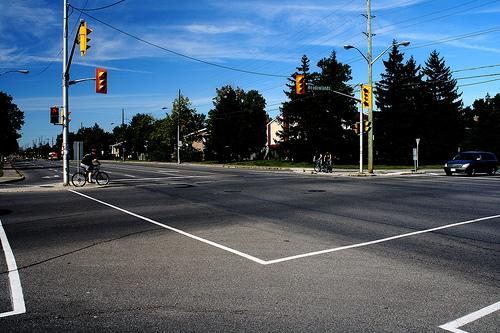How many street lights are there in the image, and what color are they? There are two yellow street lights in the image. Describe the condition of the road in the image. The road is grey colored and has solid white lines and a sewer manhole in the middle. Identify the color and type of vehicle found in the image. There is a dark blue minivan stopped at the traffic light. What type of nature element is present on the sides of the road? A row of green trees is present on the sides of the road. In the sky area of the image, what can be observed? There are white clouds in the blue sky. What type of sentiment can be inferred from the image surroundings? The image presents a calm and peaceful sentiment due to green trees and blue sky. What are the bikers waiting for at the intersection? The bikers are waiting to cross the street. What kind of lines can be seen on the pavement in the image? Thick white crosswalk lines can be seen on the pavement. Count how many bicycles there are in the image. There are a total of four bicycles in the image. What type of pole is found in the image, and what is its color? There is a tall silver light and traffic signal pole, which is grey in color. 